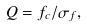Convert formula to latex. <formula><loc_0><loc_0><loc_500><loc_500>Q = f _ { c } / \sigma _ { f } ,</formula> 